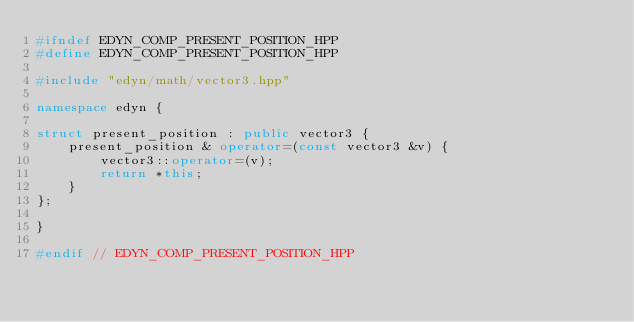Convert code to text. <code><loc_0><loc_0><loc_500><loc_500><_C++_>#ifndef EDYN_COMP_PRESENT_POSITION_HPP
#define EDYN_COMP_PRESENT_POSITION_HPP

#include "edyn/math/vector3.hpp"

namespace edyn {

struct present_position : public vector3 {
    present_position & operator=(const vector3 &v) {
        vector3::operator=(v);
        return *this;
    }
};

}

#endif // EDYN_COMP_PRESENT_POSITION_HPP
</code> 